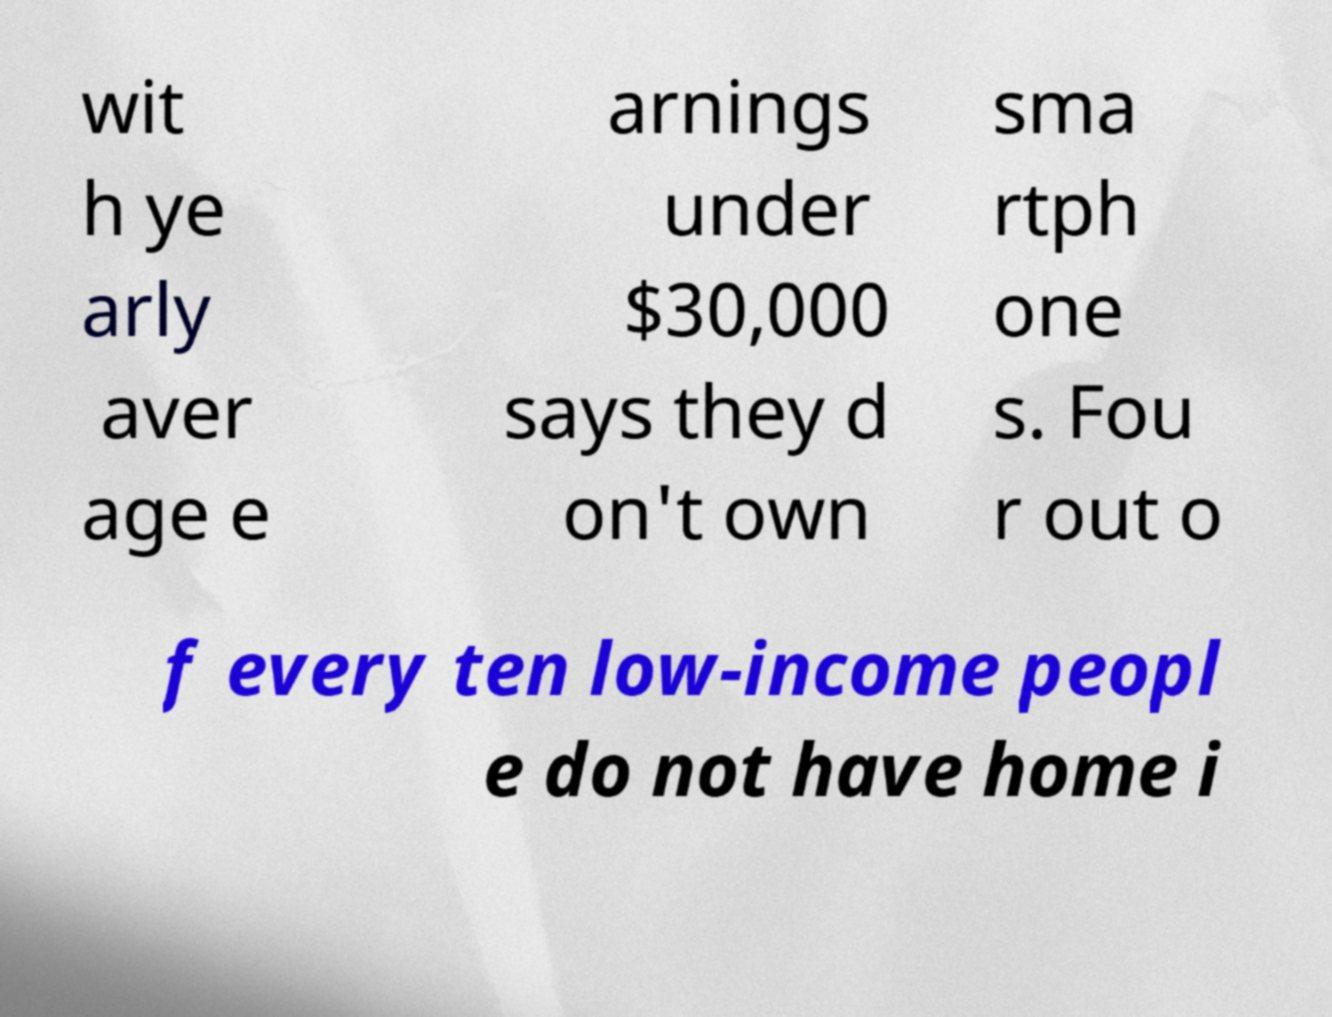What messages or text are displayed in this image? I need them in a readable, typed format. wit h ye arly aver age e arnings under $30,000 says they d on't own sma rtph one s. Fou r out o f every ten low-income peopl e do not have home i 